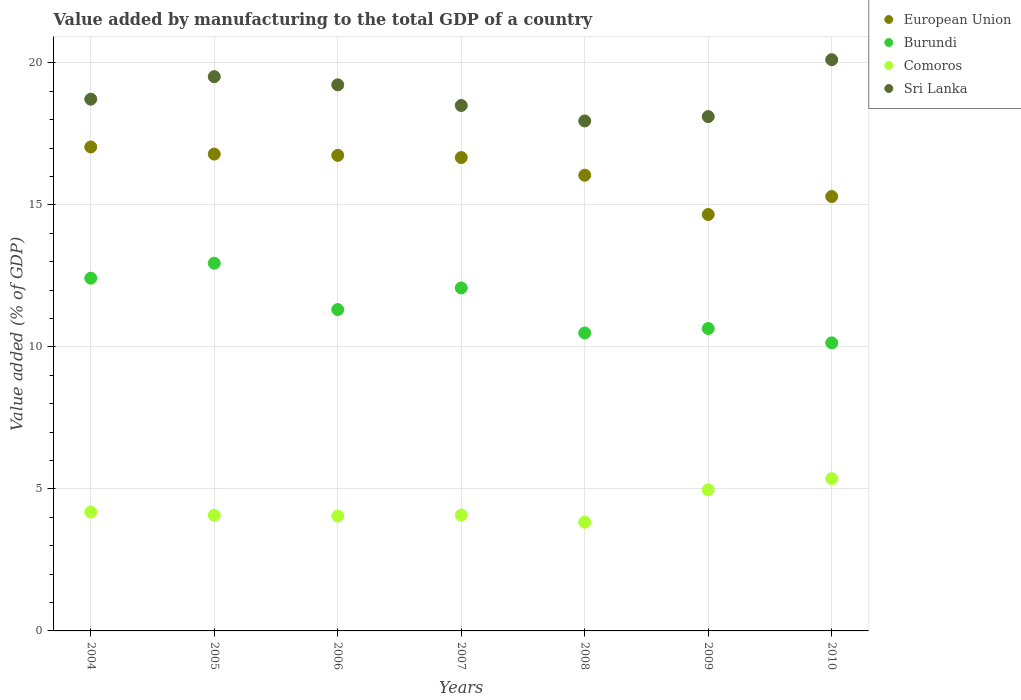What is the value added by manufacturing to the total GDP in Burundi in 2006?
Provide a short and direct response. 11.31. Across all years, what is the maximum value added by manufacturing to the total GDP in Comoros?
Provide a short and direct response. 5.36. Across all years, what is the minimum value added by manufacturing to the total GDP in Comoros?
Offer a terse response. 3.83. In which year was the value added by manufacturing to the total GDP in European Union minimum?
Provide a short and direct response. 2009. What is the total value added by manufacturing to the total GDP in Burundi in the graph?
Give a very brief answer. 80.03. What is the difference between the value added by manufacturing to the total GDP in Comoros in 2004 and that in 2009?
Your response must be concise. -0.78. What is the difference between the value added by manufacturing to the total GDP in Sri Lanka in 2004 and the value added by manufacturing to the total GDP in Burundi in 2007?
Keep it short and to the point. 6.65. What is the average value added by manufacturing to the total GDP in European Union per year?
Provide a succinct answer. 16.18. In the year 2010, what is the difference between the value added by manufacturing to the total GDP in Sri Lanka and value added by manufacturing to the total GDP in European Union?
Offer a very short reply. 4.82. In how many years, is the value added by manufacturing to the total GDP in Burundi greater than 17 %?
Your response must be concise. 0. What is the ratio of the value added by manufacturing to the total GDP in Sri Lanka in 2004 to that in 2007?
Offer a terse response. 1.01. Is the value added by manufacturing to the total GDP in European Union in 2004 less than that in 2007?
Provide a succinct answer. No. Is the difference between the value added by manufacturing to the total GDP in Sri Lanka in 2004 and 2010 greater than the difference between the value added by manufacturing to the total GDP in European Union in 2004 and 2010?
Keep it short and to the point. No. What is the difference between the highest and the second highest value added by manufacturing to the total GDP in Comoros?
Make the answer very short. 0.39. What is the difference between the highest and the lowest value added by manufacturing to the total GDP in Burundi?
Ensure brevity in your answer.  2.8. Is the sum of the value added by manufacturing to the total GDP in Burundi in 2006 and 2007 greater than the maximum value added by manufacturing to the total GDP in Sri Lanka across all years?
Offer a very short reply. Yes. Is it the case that in every year, the sum of the value added by manufacturing to the total GDP in European Union and value added by manufacturing to the total GDP in Sri Lanka  is greater than the sum of value added by manufacturing to the total GDP in Burundi and value added by manufacturing to the total GDP in Comoros?
Your response must be concise. Yes. Is it the case that in every year, the sum of the value added by manufacturing to the total GDP in Sri Lanka and value added by manufacturing to the total GDP in Burundi  is greater than the value added by manufacturing to the total GDP in European Union?
Make the answer very short. Yes. Is the value added by manufacturing to the total GDP in Sri Lanka strictly greater than the value added by manufacturing to the total GDP in Burundi over the years?
Your response must be concise. Yes. Is the value added by manufacturing to the total GDP in Sri Lanka strictly less than the value added by manufacturing to the total GDP in Comoros over the years?
Your answer should be compact. No. How many years are there in the graph?
Your answer should be compact. 7. What is the difference between two consecutive major ticks on the Y-axis?
Offer a terse response. 5. Are the values on the major ticks of Y-axis written in scientific E-notation?
Offer a very short reply. No. Where does the legend appear in the graph?
Provide a succinct answer. Top right. What is the title of the graph?
Provide a succinct answer. Value added by manufacturing to the total GDP of a country. What is the label or title of the Y-axis?
Offer a very short reply. Value added (% of GDP). What is the Value added (% of GDP) in European Union in 2004?
Provide a short and direct response. 17.04. What is the Value added (% of GDP) of Burundi in 2004?
Provide a short and direct response. 12.42. What is the Value added (% of GDP) in Comoros in 2004?
Ensure brevity in your answer.  4.19. What is the Value added (% of GDP) in Sri Lanka in 2004?
Keep it short and to the point. 18.72. What is the Value added (% of GDP) in European Union in 2005?
Make the answer very short. 16.79. What is the Value added (% of GDP) in Burundi in 2005?
Make the answer very short. 12.95. What is the Value added (% of GDP) of Comoros in 2005?
Keep it short and to the point. 4.07. What is the Value added (% of GDP) of Sri Lanka in 2005?
Your response must be concise. 19.51. What is the Value added (% of GDP) of European Union in 2006?
Ensure brevity in your answer.  16.74. What is the Value added (% of GDP) in Burundi in 2006?
Make the answer very short. 11.31. What is the Value added (% of GDP) in Comoros in 2006?
Give a very brief answer. 4.04. What is the Value added (% of GDP) in Sri Lanka in 2006?
Offer a very short reply. 19.23. What is the Value added (% of GDP) of European Union in 2007?
Make the answer very short. 16.67. What is the Value added (% of GDP) in Burundi in 2007?
Provide a succinct answer. 12.07. What is the Value added (% of GDP) in Comoros in 2007?
Keep it short and to the point. 4.08. What is the Value added (% of GDP) in Sri Lanka in 2007?
Make the answer very short. 18.5. What is the Value added (% of GDP) of European Union in 2008?
Give a very brief answer. 16.04. What is the Value added (% of GDP) of Burundi in 2008?
Offer a very short reply. 10.49. What is the Value added (% of GDP) of Comoros in 2008?
Make the answer very short. 3.83. What is the Value added (% of GDP) of Sri Lanka in 2008?
Provide a short and direct response. 17.95. What is the Value added (% of GDP) in European Union in 2009?
Ensure brevity in your answer.  14.66. What is the Value added (% of GDP) in Burundi in 2009?
Your response must be concise. 10.65. What is the Value added (% of GDP) of Comoros in 2009?
Keep it short and to the point. 4.97. What is the Value added (% of GDP) in Sri Lanka in 2009?
Keep it short and to the point. 18.11. What is the Value added (% of GDP) of European Union in 2010?
Your answer should be compact. 15.29. What is the Value added (% of GDP) of Burundi in 2010?
Ensure brevity in your answer.  10.14. What is the Value added (% of GDP) in Comoros in 2010?
Keep it short and to the point. 5.36. What is the Value added (% of GDP) in Sri Lanka in 2010?
Make the answer very short. 20.11. Across all years, what is the maximum Value added (% of GDP) of European Union?
Your answer should be very brief. 17.04. Across all years, what is the maximum Value added (% of GDP) of Burundi?
Make the answer very short. 12.95. Across all years, what is the maximum Value added (% of GDP) of Comoros?
Your response must be concise. 5.36. Across all years, what is the maximum Value added (% of GDP) of Sri Lanka?
Provide a short and direct response. 20.11. Across all years, what is the minimum Value added (% of GDP) of European Union?
Keep it short and to the point. 14.66. Across all years, what is the minimum Value added (% of GDP) of Burundi?
Your answer should be compact. 10.14. Across all years, what is the minimum Value added (% of GDP) of Comoros?
Provide a succinct answer. 3.83. Across all years, what is the minimum Value added (% of GDP) of Sri Lanka?
Ensure brevity in your answer.  17.95. What is the total Value added (% of GDP) of European Union in the graph?
Ensure brevity in your answer.  113.23. What is the total Value added (% of GDP) of Burundi in the graph?
Your response must be concise. 80.03. What is the total Value added (% of GDP) of Comoros in the graph?
Offer a terse response. 30.53. What is the total Value added (% of GDP) in Sri Lanka in the graph?
Your answer should be very brief. 132.13. What is the difference between the Value added (% of GDP) of European Union in 2004 and that in 2005?
Ensure brevity in your answer.  0.25. What is the difference between the Value added (% of GDP) in Burundi in 2004 and that in 2005?
Make the answer very short. -0.53. What is the difference between the Value added (% of GDP) in Comoros in 2004 and that in 2005?
Your response must be concise. 0.12. What is the difference between the Value added (% of GDP) in Sri Lanka in 2004 and that in 2005?
Keep it short and to the point. -0.79. What is the difference between the Value added (% of GDP) in European Union in 2004 and that in 2006?
Your answer should be compact. 0.29. What is the difference between the Value added (% of GDP) in Burundi in 2004 and that in 2006?
Provide a succinct answer. 1.11. What is the difference between the Value added (% of GDP) in Comoros in 2004 and that in 2006?
Make the answer very short. 0.14. What is the difference between the Value added (% of GDP) in Sri Lanka in 2004 and that in 2006?
Offer a very short reply. -0.51. What is the difference between the Value added (% of GDP) in European Union in 2004 and that in 2007?
Your answer should be compact. 0.37. What is the difference between the Value added (% of GDP) in Burundi in 2004 and that in 2007?
Your response must be concise. 0.34. What is the difference between the Value added (% of GDP) in Comoros in 2004 and that in 2007?
Provide a succinct answer. 0.11. What is the difference between the Value added (% of GDP) of Sri Lanka in 2004 and that in 2007?
Make the answer very short. 0.22. What is the difference between the Value added (% of GDP) of European Union in 2004 and that in 2008?
Your response must be concise. 0.99. What is the difference between the Value added (% of GDP) in Burundi in 2004 and that in 2008?
Offer a terse response. 1.93. What is the difference between the Value added (% of GDP) in Comoros in 2004 and that in 2008?
Make the answer very short. 0.36. What is the difference between the Value added (% of GDP) in Sri Lanka in 2004 and that in 2008?
Ensure brevity in your answer.  0.77. What is the difference between the Value added (% of GDP) of European Union in 2004 and that in 2009?
Offer a very short reply. 2.38. What is the difference between the Value added (% of GDP) of Burundi in 2004 and that in 2009?
Give a very brief answer. 1.77. What is the difference between the Value added (% of GDP) in Comoros in 2004 and that in 2009?
Your answer should be very brief. -0.78. What is the difference between the Value added (% of GDP) of Sri Lanka in 2004 and that in 2009?
Ensure brevity in your answer.  0.61. What is the difference between the Value added (% of GDP) in European Union in 2004 and that in 2010?
Ensure brevity in your answer.  1.74. What is the difference between the Value added (% of GDP) of Burundi in 2004 and that in 2010?
Offer a terse response. 2.28. What is the difference between the Value added (% of GDP) of Comoros in 2004 and that in 2010?
Your response must be concise. -1.17. What is the difference between the Value added (% of GDP) of Sri Lanka in 2004 and that in 2010?
Provide a short and direct response. -1.39. What is the difference between the Value added (% of GDP) in European Union in 2005 and that in 2006?
Provide a succinct answer. 0.04. What is the difference between the Value added (% of GDP) of Burundi in 2005 and that in 2006?
Provide a short and direct response. 1.63. What is the difference between the Value added (% of GDP) of Comoros in 2005 and that in 2006?
Offer a terse response. 0.03. What is the difference between the Value added (% of GDP) in Sri Lanka in 2005 and that in 2006?
Make the answer very short. 0.29. What is the difference between the Value added (% of GDP) of European Union in 2005 and that in 2007?
Offer a terse response. 0.12. What is the difference between the Value added (% of GDP) in Burundi in 2005 and that in 2007?
Provide a short and direct response. 0.87. What is the difference between the Value added (% of GDP) of Comoros in 2005 and that in 2007?
Give a very brief answer. -0.01. What is the difference between the Value added (% of GDP) in Sri Lanka in 2005 and that in 2007?
Offer a very short reply. 1.02. What is the difference between the Value added (% of GDP) in European Union in 2005 and that in 2008?
Give a very brief answer. 0.74. What is the difference between the Value added (% of GDP) of Burundi in 2005 and that in 2008?
Your answer should be very brief. 2.46. What is the difference between the Value added (% of GDP) of Comoros in 2005 and that in 2008?
Offer a terse response. 0.24. What is the difference between the Value added (% of GDP) in Sri Lanka in 2005 and that in 2008?
Give a very brief answer. 1.56. What is the difference between the Value added (% of GDP) of European Union in 2005 and that in 2009?
Offer a terse response. 2.13. What is the difference between the Value added (% of GDP) in Burundi in 2005 and that in 2009?
Offer a terse response. 2.3. What is the difference between the Value added (% of GDP) of Comoros in 2005 and that in 2009?
Give a very brief answer. -0.9. What is the difference between the Value added (% of GDP) in Sri Lanka in 2005 and that in 2009?
Your answer should be very brief. 1.41. What is the difference between the Value added (% of GDP) in European Union in 2005 and that in 2010?
Provide a succinct answer. 1.49. What is the difference between the Value added (% of GDP) in Burundi in 2005 and that in 2010?
Provide a succinct answer. 2.8. What is the difference between the Value added (% of GDP) of Comoros in 2005 and that in 2010?
Your response must be concise. -1.29. What is the difference between the Value added (% of GDP) of Sri Lanka in 2005 and that in 2010?
Offer a terse response. -0.6. What is the difference between the Value added (% of GDP) of European Union in 2006 and that in 2007?
Your answer should be compact. 0.08. What is the difference between the Value added (% of GDP) in Burundi in 2006 and that in 2007?
Make the answer very short. -0.76. What is the difference between the Value added (% of GDP) of Comoros in 2006 and that in 2007?
Provide a short and direct response. -0.03. What is the difference between the Value added (% of GDP) in Sri Lanka in 2006 and that in 2007?
Ensure brevity in your answer.  0.73. What is the difference between the Value added (% of GDP) in European Union in 2006 and that in 2008?
Keep it short and to the point. 0.7. What is the difference between the Value added (% of GDP) of Burundi in 2006 and that in 2008?
Your response must be concise. 0.82. What is the difference between the Value added (% of GDP) in Comoros in 2006 and that in 2008?
Keep it short and to the point. 0.22. What is the difference between the Value added (% of GDP) in Sri Lanka in 2006 and that in 2008?
Offer a very short reply. 1.27. What is the difference between the Value added (% of GDP) of European Union in 2006 and that in 2009?
Your answer should be very brief. 2.08. What is the difference between the Value added (% of GDP) of Burundi in 2006 and that in 2009?
Provide a succinct answer. 0.67. What is the difference between the Value added (% of GDP) in Comoros in 2006 and that in 2009?
Provide a short and direct response. -0.92. What is the difference between the Value added (% of GDP) in Sri Lanka in 2006 and that in 2009?
Give a very brief answer. 1.12. What is the difference between the Value added (% of GDP) in European Union in 2006 and that in 2010?
Give a very brief answer. 1.45. What is the difference between the Value added (% of GDP) in Burundi in 2006 and that in 2010?
Provide a short and direct response. 1.17. What is the difference between the Value added (% of GDP) of Comoros in 2006 and that in 2010?
Give a very brief answer. -1.32. What is the difference between the Value added (% of GDP) in Sri Lanka in 2006 and that in 2010?
Your response must be concise. -0.88. What is the difference between the Value added (% of GDP) in European Union in 2007 and that in 2008?
Give a very brief answer. 0.62. What is the difference between the Value added (% of GDP) in Burundi in 2007 and that in 2008?
Offer a terse response. 1.58. What is the difference between the Value added (% of GDP) of Comoros in 2007 and that in 2008?
Ensure brevity in your answer.  0.25. What is the difference between the Value added (% of GDP) of Sri Lanka in 2007 and that in 2008?
Your response must be concise. 0.54. What is the difference between the Value added (% of GDP) of European Union in 2007 and that in 2009?
Your answer should be compact. 2. What is the difference between the Value added (% of GDP) in Burundi in 2007 and that in 2009?
Give a very brief answer. 1.43. What is the difference between the Value added (% of GDP) in Comoros in 2007 and that in 2009?
Provide a succinct answer. -0.89. What is the difference between the Value added (% of GDP) of Sri Lanka in 2007 and that in 2009?
Offer a terse response. 0.39. What is the difference between the Value added (% of GDP) in European Union in 2007 and that in 2010?
Make the answer very short. 1.37. What is the difference between the Value added (% of GDP) in Burundi in 2007 and that in 2010?
Give a very brief answer. 1.93. What is the difference between the Value added (% of GDP) in Comoros in 2007 and that in 2010?
Offer a terse response. -1.28. What is the difference between the Value added (% of GDP) in Sri Lanka in 2007 and that in 2010?
Offer a very short reply. -1.61. What is the difference between the Value added (% of GDP) of European Union in 2008 and that in 2009?
Your answer should be compact. 1.38. What is the difference between the Value added (% of GDP) of Burundi in 2008 and that in 2009?
Keep it short and to the point. -0.16. What is the difference between the Value added (% of GDP) in Comoros in 2008 and that in 2009?
Ensure brevity in your answer.  -1.14. What is the difference between the Value added (% of GDP) in Sri Lanka in 2008 and that in 2009?
Provide a short and direct response. -0.15. What is the difference between the Value added (% of GDP) of European Union in 2008 and that in 2010?
Your answer should be compact. 0.75. What is the difference between the Value added (% of GDP) in Burundi in 2008 and that in 2010?
Keep it short and to the point. 0.35. What is the difference between the Value added (% of GDP) in Comoros in 2008 and that in 2010?
Your answer should be compact. -1.53. What is the difference between the Value added (% of GDP) of Sri Lanka in 2008 and that in 2010?
Ensure brevity in your answer.  -2.16. What is the difference between the Value added (% of GDP) in European Union in 2009 and that in 2010?
Your response must be concise. -0.63. What is the difference between the Value added (% of GDP) of Burundi in 2009 and that in 2010?
Give a very brief answer. 0.5. What is the difference between the Value added (% of GDP) in Comoros in 2009 and that in 2010?
Offer a terse response. -0.39. What is the difference between the Value added (% of GDP) in Sri Lanka in 2009 and that in 2010?
Your answer should be compact. -2. What is the difference between the Value added (% of GDP) of European Union in 2004 and the Value added (% of GDP) of Burundi in 2005?
Ensure brevity in your answer.  4.09. What is the difference between the Value added (% of GDP) in European Union in 2004 and the Value added (% of GDP) in Comoros in 2005?
Ensure brevity in your answer.  12.97. What is the difference between the Value added (% of GDP) of European Union in 2004 and the Value added (% of GDP) of Sri Lanka in 2005?
Your response must be concise. -2.48. What is the difference between the Value added (% of GDP) of Burundi in 2004 and the Value added (% of GDP) of Comoros in 2005?
Your response must be concise. 8.35. What is the difference between the Value added (% of GDP) in Burundi in 2004 and the Value added (% of GDP) in Sri Lanka in 2005?
Ensure brevity in your answer.  -7.09. What is the difference between the Value added (% of GDP) of Comoros in 2004 and the Value added (% of GDP) of Sri Lanka in 2005?
Provide a succinct answer. -15.33. What is the difference between the Value added (% of GDP) in European Union in 2004 and the Value added (% of GDP) in Burundi in 2006?
Offer a very short reply. 5.72. What is the difference between the Value added (% of GDP) in European Union in 2004 and the Value added (% of GDP) in Comoros in 2006?
Your response must be concise. 12.99. What is the difference between the Value added (% of GDP) in European Union in 2004 and the Value added (% of GDP) in Sri Lanka in 2006?
Provide a short and direct response. -2.19. What is the difference between the Value added (% of GDP) in Burundi in 2004 and the Value added (% of GDP) in Comoros in 2006?
Keep it short and to the point. 8.37. What is the difference between the Value added (% of GDP) in Burundi in 2004 and the Value added (% of GDP) in Sri Lanka in 2006?
Your response must be concise. -6.81. What is the difference between the Value added (% of GDP) in Comoros in 2004 and the Value added (% of GDP) in Sri Lanka in 2006?
Ensure brevity in your answer.  -15.04. What is the difference between the Value added (% of GDP) in European Union in 2004 and the Value added (% of GDP) in Burundi in 2007?
Keep it short and to the point. 4.96. What is the difference between the Value added (% of GDP) in European Union in 2004 and the Value added (% of GDP) in Comoros in 2007?
Offer a terse response. 12.96. What is the difference between the Value added (% of GDP) of European Union in 2004 and the Value added (% of GDP) of Sri Lanka in 2007?
Offer a terse response. -1.46. What is the difference between the Value added (% of GDP) of Burundi in 2004 and the Value added (% of GDP) of Comoros in 2007?
Your answer should be very brief. 8.34. What is the difference between the Value added (% of GDP) in Burundi in 2004 and the Value added (% of GDP) in Sri Lanka in 2007?
Offer a very short reply. -6.08. What is the difference between the Value added (% of GDP) of Comoros in 2004 and the Value added (% of GDP) of Sri Lanka in 2007?
Offer a terse response. -14.31. What is the difference between the Value added (% of GDP) in European Union in 2004 and the Value added (% of GDP) in Burundi in 2008?
Ensure brevity in your answer.  6.55. What is the difference between the Value added (% of GDP) in European Union in 2004 and the Value added (% of GDP) in Comoros in 2008?
Keep it short and to the point. 13.21. What is the difference between the Value added (% of GDP) in European Union in 2004 and the Value added (% of GDP) in Sri Lanka in 2008?
Give a very brief answer. -0.92. What is the difference between the Value added (% of GDP) in Burundi in 2004 and the Value added (% of GDP) in Comoros in 2008?
Your answer should be very brief. 8.59. What is the difference between the Value added (% of GDP) of Burundi in 2004 and the Value added (% of GDP) of Sri Lanka in 2008?
Offer a terse response. -5.54. What is the difference between the Value added (% of GDP) in Comoros in 2004 and the Value added (% of GDP) in Sri Lanka in 2008?
Your answer should be compact. -13.77. What is the difference between the Value added (% of GDP) in European Union in 2004 and the Value added (% of GDP) in Burundi in 2009?
Your answer should be very brief. 6.39. What is the difference between the Value added (% of GDP) in European Union in 2004 and the Value added (% of GDP) in Comoros in 2009?
Offer a very short reply. 12.07. What is the difference between the Value added (% of GDP) in European Union in 2004 and the Value added (% of GDP) in Sri Lanka in 2009?
Provide a short and direct response. -1.07. What is the difference between the Value added (% of GDP) of Burundi in 2004 and the Value added (% of GDP) of Comoros in 2009?
Keep it short and to the point. 7.45. What is the difference between the Value added (% of GDP) of Burundi in 2004 and the Value added (% of GDP) of Sri Lanka in 2009?
Your answer should be very brief. -5.69. What is the difference between the Value added (% of GDP) of Comoros in 2004 and the Value added (% of GDP) of Sri Lanka in 2009?
Ensure brevity in your answer.  -13.92. What is the difference between the Value added (% of GDP) of European Union in 2004 and the Value added (% of GDP) of Burundi in 2010?
Offer a terse response. 6.9. What is the difference between the Value added (% of GDP) of European Union in 2004 and the Value added (% of GDP) of Comoros in 2010?
Give a very brief answer. 11.68. What is the difference between the Value added (% of GDP) of European Union in 2004 and the Value added (% of GDP) of Sri Lanka in 2010?
Provide a succinct answer. -3.07. What is the difference between the Value added (% of GDP) of Burundi in 2004 and the Value added (% of GDP) of Comoros in 2010?
Keep it short and to the point. 7.06. What is the difference between the Value added (% of GDP) of Burundi in 2004 and the Value added (% of GDP) of Sri Lanka in 2010?
Give a very brief answer. -7.69. What is the difference between the Value added (% of GDP) of Comoros in 2004 and the Value added (% of GDP) of Sri Lanka in 2010?
Make the answer very short. -15.92. What is the difference between the Value added (% of GDP) in European Union in 2005 and the Value added (% of GDP) in Burundi in 2006?
Your answer should be very brief. 5.47. What is the difference between the Value added (% of GDP) of European Union in 2005 and the Value added (% of GDP) of Comoros in 2006?
Your answer should be very brief. 12.74. What is the difference between the Value added (% of GDP) of European Union in 2005 and the Value added (% of GDP) of Sri Lanka in 2006?
Provide a succinct answer. -2.44. What is the difference between the Value added (% of GDP) in Burundi in 2005 and the Value added (% of GDP) in Comoros in 2006?
Offer a very short reply. 8.9. What is the difference between the Value added (% of GDP) in Burundi in 2005 and the Value added (% of GDP) in Sri Lanka in 2006?
Offer a terse response. -6.28. What is the difference between the Value added (% of GDP) of Comoros in 2005 and the Value added (% of GDP) of Sri Lanka in 2006?
Your answer should be compact. -15.16. What is the difference between the Value added (% of GDP) of European Union in 2005 and the Value added (% of GDP) of Burundi in 2007?
Keep it short and to the point. 4.71. What is the difference between the Value added (% of GDP) in European Union in 2005 and the Value added (% of GDP) in Comoros in 2007?
Your response must be concise. 12.71. What is the difference between the Value added (% of GDP) in European Union in 2005 and the Value added (% of GDP) in Sri Lanka in 2007?
Give a very brief answer. -1.71. What is the difference between the Value added (% of GDP) in Burundi in 2005 and the Value added (% of GDP) in Comoros in 2007?
Your response must be concise. 8.87. What is the difference between the Value added (% of GDP) in Burundi in 2005 and the Value added (% of GDP) in Sri Lanka in 2007?
Offer a very short reply. -5.55. What is the difference between the Value added (% of GDP) of Comoros in 2005 and the Value added (% of GDP) of Sri Lanka in 2007?
Provide a short and direct response. -14.43. What is the difference between the Value added (% of GDP) of European Union in 2005 and the Value added (% of GDP) of Burundi in 2008?
Provide a succinct answer. 6.3. What is the difference between the Value added (% of GDP) in European Union in 2005 and the Value added (% of GDP) in Comoros in 2008?
Offer a terse response. 12.96. What is the difference between the Value added (% of GDP) in European Union in 2005 and the Value added (% of GDP) in Sri Lanka in 2008?
Keep it short and to the point. -1.17. What is the difference between the Value added (% of GDP) in Burundi in 2005 and the Value added (% of GDP) in Comoros in 2008?
Provide a succinct answer. 9.12. What is the difference between the Value added (% of GDP) in Burundi in 2005 and the Value added (% of GDP) in Sri Lanka in 2008?
Offer a terse response. -5.01. What is the difference between the Value added (% of GDP) in Comoros in 2005 and the Value added (% of GDP) in Sri Lanka in 2008?
Keep it short and to the point. -13.88. What is the difference between the Value added (% of GDP) of European Union in 2005 and the Value added (% of GDP) of Burundi in 2009?
Your answer should be very brief. 6.14. What is the difference between the Value added (% of GDP) of European Union in 2005 and the Value added (% of GDP) of Comoros in 2009?
Your answer should be compact. 11.82. What is the difference between the Value added (% of GDP) of European Union in 2005 and the Value added (% of GDP) of Sri Lanka in 2009?
Ensure brevity in your answer.  -1.32. What is the difference between the Value added (% of GDP) of Burundi in 2005 and the Value added (% of GDP) of Comoros in 2009?
Provide a short and direct response. 7.98. What is the difference between the Value added (% of GDP) of Burundi in 2005 and the Value added (% of GDP) of Sri Lanka in 2009?
Make the answer very short. -5.16. What is the difference between the Value added (% of GDP) of Comoros in 2005 and the Value added (% of GDP) of Sri Lanka in 2009?
Offer a terse response. -14.04. What is the difference between the Value added (% of GDP) of European Union in 2005 and the Value added (% of GDP) of Burundi in 2010?
Your response must be concise. 6.64. What is the difference between the Value added (% of GDP) of European Union in 2005 and the Value added (% of GDP) of Comoros in 2010?
Your answer should be very brief. 11.43. What is the difference between the Value added (% of GDP) in European Union in 2005 and the Value added (% of GDP) in Sri Lanka in 2010?
Provide a succinct answer. -3.32. What is the difference between the Value added (% of GDP) of Burundi in 2005 and the Value added (% of GDP) of Comoros in 2010?
Offer a very short reply. 7.59. What is the difference between the Value added (% of GDP) of Burundi in 2005 and the Value added (% of GDP) of Sri Lanka in 2010?
Provide a succinct answer. -7.17. What is the difference between the Value added (% of GDP) of Comoros in 2005 and the Value added (% of GDP) of Sri Lanka in 2010?
Your answer should be very brief. -16.04. What is the difference between the Value added (% of GDP) in European Union in 2006 and the Value added (% of GDP) in Burundi in 2007?
Ensure brevity in your answer.  4.67. What is the difference between the Value added (% of GDP) in European Union in 2006 and the Value added (% of GDP) in Comoros in 2007?
Provide a short and direct response. 12.66. What is the difference between the Value added (% of GDP) of European Union in 2006 and the Value added (% of GDP) of Sri Lanka in 2007?
Provide a succinct answer. -1.76. What is the difference between the Value added (% of GDP) in Burundi in 2006 and the Value added (% of GDP) in Comoros in 2007?
Make the answer very short. 7.23. What is the difference between the Value added (% of GDP) in Burundi in 2006 and the Value added (% of GDP) in Sri Lanka in 2007?
Make the answer very short. -7.18. What is the difference between the Value added (% of GDP) in Comoros in 2006 and the Value added (% of GDP) in Sri Lanka in 2007?
Offer a very short reply. -14.45. What is the difference between the Value added (% of GDP) in European Union in 2006 and the Value added (% of GDP) in Burundi in 2008?
Your response must be concise. 6.25. What is the difference between the Value added (% of GDP) of European Union in 2006 and the Value added (% of GDP) of Comoros in 2008?
Ensure brevity in your answer.  12.91. What is the difference between the Value added (% of GDP) in European Union in 2006 and the Value added (% of GDP) in Sri Lanka in 2008?
Provide a succinct answer. -1.21. What is the difference between the Value added (% of GDP) in Burundi in 2006 and the Value added (% of GDP) in Comoros in 2008?
Offer a very short reply. 7.48. What is the difference between the Value added (% of GDP) in Burundi in 2006 and the Value added (% of GDP) in Sri Lanka in 2008?
Your answer should be very brief. -6.64. What is the difference between the Value added (% of GDP) of Comoros in 2006 and the Value added (% of GDP) of Sri Lanka in 2008?
Provide a succinct answer. -13.91. What is the difference between the Value added (% of GDP) in European Union in 2006 and the Value added (% of GDP) in Burundi in 2009?
Provide a short and direct response. 6.1. What is the difference between the Value added (% of GDP) of European Union in 2006 and the Value added (% of GDP) of Comoros in 2009?
Ensure brevity in your answer.  11.78. What is the difference between the Value added (% of GDP) in European Union in 2006 and the Value added (% of GDP) in Sri Lanka in 2009?
Provide a succinct answer. -1.36. What is the difference between the Value added (% of GDP) of Burundi in 2006 and the Value added (% of GDP) of Comoros in 2009?
Your answer should be very brief. 6.35. What is the difference between the Value added (% of GDP) of Burundi in 2006 and the Value added (% of GDP) of Sri Lanka in 2009?
Keep it short and to the point. -6.79. What is the difference between the Value added (% of GDP) of Comoros in 2006 and the Value added (% of GDP) of Sri Lanka in 2009?
Provide a short and direct response. -14.06. What is the difference between the Value added (% of GDP) in European Union in 2006 and the Value added (% of GDP) in Burundi in 2010?
Give a very brief answer. 6.6. What is the difference between the Value added (% of GDP) of European Union in 2006 and the Value added (% of GDP) of Comoros in 2010?
Provide a succinct answer. 11.38. What is the difference between the Value added (% of GDP) in European Union in 2006 and the Value added (% of GDP) in Sri Lanka in 2010?
Give a very brief answer. -3.37. What is the difference between the Value added (% of GDP) of Burundi in 2006 and the Value added (% of GDP) of Comoros in 2010?
Your response must be concise. 5.95. What is the difference between the Value added (% of GDP) in Burundi in 2006 and the Value added (% of GDP) in Sri Lanka in 2010?
Offer a very short reply. -8.8. What is the difference between the Value added (% of GDP) of Comoros in 2006 and the Value added (% of GDP) of Sri Lanka in 2010?
Offer a terse response. -16.07. What is the difference between the Value added (% of GDP) of European Union in 2007 and the Value added (% of GDP) of Burundi in 2008?
Ensure brevity in your answer.  6.18. What is the difference between the Value added (% of GDP) in European Union in 2007 and the Value added (% of GDP) in Comoros in 2008?
Your answer should be very brief. 12.84. What is the difference between the Value added (% of GDP) of European Union in 2007 and the Value added (% of GDP) of Sri Lanka in 2008?
Ensure brevity in your answer.  -1.29. What is the difference between the Value added (% of GDP) in Burundi in 2007 and the Value added (% of GDP) in Comoros in 2008?
Ensure brevity in your answer.  8.25. What is the difference between the Value added (% of GDP) of Burundi in 2007 and the Value added (% of GDP) of Sri Lanka in 2008?
Make the answer very short. -5.88. What is the difference between the Value added (% of GDP) in Comoros in 2007 and the Value added (% of GDP) in Sri Lanka in 2008?
Your response must be concise. -13.88. What is the difference between the Value added (% of GDP) in European Union in 2007 and the Value added (% of GDP) in Burundi in 2009?
Offer a terse response. 6.02. What is the difference between the Value added (% of GDP) in European Union in 2007 and the Value added (% of GDP) in Comoros in 2009?
Ensure brevity in your answer.  11.7. What is the difference between the Value added (% of GDP) in European Union in 2007 and the Value added (% of GDP) in Sri Lanka in 2009?
Offer a very short reply. -1.44. What is the difference between the Value added (% of GDP) of Burundi in 2007 and the Value added (% of GDP) of Comoros in 2009?
Provide a succinct answer. 7.11. What is the difference between the Value added (% of GDP) in Burundi in 2007 and the Value added (% of GDP) in Sri Lanka in 2009?
Your answer should be very brief. -6.03. What is the difference between the Value added (% of GDP) of Comoros in 2007 and the Value added (% of GDP) of Sri Lanka in 2009?
Provide a short and direct response. -14.03. What is the difference between the Value added (% of GDP) in European Union in 2007 and the Value added (% of GDP) in Burundi in 2010?
Give a very brief answer. 6.52. What is the difference between the Value added (% of GDP) in European Union in 2007 and the Value added (% of GDP) in Comoros in 2010?
Offer a terse response. 11.31. What is the difference between the Value added (% of GDP) in European Union in 2007 and the Value added (% of GDP) in Sri Lanka in 2010?
Your response must be concise. -3.45. What is the difference between the Value added (% of GDP) of Burundi in 2007 and the Value added (% of GDP) of Comoros in 2010?
Offer a very short reply. 6.72. What is the difference between the Value added (% of GDP) in Burundi in 2007 and the Value added (% of GDP) in Sri Lanka in 2010?
Keep it short and to the point. -8.04. What is the difference between the Value added (% of GDP) of Comoros in 2007 and the Value added (% of GDP) of Sri Lanka in 2010?
Provide a succinct answer. -16.03. What is the difference between the Value added (% of GDP) in European Union in 2008 and the Value added (% of GDP) in Burundi in 2009?
Keep it short and to the point. 5.4. What is the difference between the Value added (% of GDP) of European Union in 2008 and the Value added (% of GDP) of Comoros in 2009?
Your answer should be compact. 11.08. What is the difference between the Value added (% of GDP) of European Union in 2008 and the Value added (% of GDP) of Sri Lanka in 2009?
Provide a short and direct response. -2.06. What is the difference between the Value added (% of GDP) of Burundi in 2008 and the Value added (% of GDP) of Comoros in 2009?
Make the answer very short. 5.52. What is the difference between the Value added (% of GDP) of Burundi in 2008 and the Value added (% of GDP) of Sri Lanka in 2009?
Your response must be concise. -7.62. What is the difference between the Value added (% of GDP) of Comoros in 2008 and the Value added (% of GDP) of Sri Lanka in 2009?
Offer a very short reply. -14.28. What is the difference between the Value added (% of GDP) in European Union in 2008 and the Value added (% of GDP) in Burundi in 2010?
Your response must be concise. 5.9. What is the difference between the Value added (% of GDP) in European Union in 2008 and the Value added (% of GDP) in Comoros in 2010?
Offer a terse response. 10.68. What is the difference between the Value added (% of GDP) of European Union in 2008 and the Value added (% of GDP) of Sri Lanka in 2010?
Your response must be concise. -4.07. What is the difference between the Value added (% of GDP) in Burundi in 2008 and the Value added (% of GDP) in Comoros in 2010?
Provide a short and direct response. 5.13. What is the difference between the Value added (% of GDP) in Burundi in 2008 and the Value added (% of GDP) in Sri Lanka in 2010?
Keep it short and to the point. -9.62. What is the difference between the Value added (% of GDP) in Comoros in 2008 and the Value added (% of GDP) in Sri Lanka in 2010?
Offer a terse response. -16.28. What is the difference between the Value added (% of GDP) in European Union in 2009 and the Value added (% of GDP) in Burundi in 2010?
Offer a terse response. 4.52. What is the difference between the Value added (% of GDP) in European Union in 2009 and the Value added (% of GDP) in Comoros in 2010?
Your response must be concise. 9.3. What is the difference between the Value added (% of GDP) in European Union in 2009 and the Value added (% of GDP) in Sri Lanka in 2010?
Your answer should be compact. -5.45. What is the difference between the Value added (% of GDP) in Burundi in 2009 and the Value added (% of GDP) in Comoros in 2010?
Offer a very short reply. 5.29. What is the difference between the Value added (% of GDP) in Burundi in 2009 and the Value added (% of GDP) in Sri Lanka in 2010?
Make the answer very short. -9.46. What is the difference between the Value added (% of GDP) in Comoros in 2009 and the Value added (% of GDP) in Sri Lanka in 2010?
Provide a short and direct response. -15.14. What is the average Value added (% of GDP) of European Union per year?
Provide a succinct answer. 16.18. What is the average Value added (% of GDP) in Burundi per year?
Your response must be concise. 11.43. What is the average Value added (% of GDP) of Comoros per year?
Ensure brevity in your answer.  4.36. What is the average Value added (% of GDP) of Sri Lanka per year?
Ensure brevity in your answer.  18.88. In the year 2004, what is the difference between the Value added (% of GDP) of European Union and Value added (% of GDP) of Burundi?
Give a very brief answer. 4.62. In the year 2004, what is the difference between the Value added (% of GDP) of European Union and Value added (% of GDP) of Comoros?
Your answer should be very brief. 12.85. In the year 2004, what is the difference between the Value added (% of GDP) of European Union and Value added (% of GDP) of Sri Lanka?
Give a very brief answer. -1.68. In the year 2004, what is the difference between the Value added (% of GDP) of Burundi and Value added (% of GDP) of Comoros?
Offer a terse response. 8.23. In the year 2004, what is the difference between the Value added (% of GDP) in Burundi and Value added (% of GDP) in Sri Lanka?
Offer a very short reply. -6.3. In the year 2004, what is the difference between the Value added (% of GDP) of Comoros and Value added (% of GDP) of Sri Lanka?
Give a very brief answer. -14.53. In the year 2005, what is the difference between the Value added (% of GDP) of European Union and Value added (% of GDP) of Burundi?
Provide a short and direct response. 3.84. In the year 2005, what is the difference between the Value added (% of GDP) in European Union and Value added (% of GDP) in Comoros?
Your answer should be very brief. 12.72. In the year 2005, what is the difference between the Value added (% of GDP) in European Union and Value added (% of GDP) in Sri Lanka?
Provide a short and direct response. -2.73. In the year 2005, what is the difference between the Value added (% of GDP) of Burundi and Value added (% of GDP) of Comoros?
Your response must be concise. 8.87. In the year 2005, what is the difference between the Value added (% of GDP) in Burundi and Value added (% of GDP) in Sri Lanka?
Ensure brevity in your answer.  -6.57. In the year 2005, what is the difference between the Value added (% of GDP) in Comoros and Value added (% of GDP) in Sri Lanka?
Your answer should be compact. -15.44. In the year 2006, what is the difference between the Value added (% of GDP) of European Union and Value added (% of GDP) of Burundi?
Your answer should be compact. 5.43. In the year 2006, what is the difference between the Value added (% of GDP) in European Union and Value added (% of GDP) in Comoros?
Your answer should be very brief. 12.7. In the year 2006, what is the difference between the Value added (% of GDP) of European Union and Value added (% of GDP) of Sri Lanka?
Offer a terse response. -2.48. In the year 2006, what is the difference between the Value added (% of GDP) in Burundi and Value added (% of GDP) in Comoros?
Your response must be concise. 7.27. In the year 2006, what is the difference between the Value added (% of GDP) in Burundi and Value added (% of GDP) in Sri Lanka?
Provide a succinct answer. -7.91. In the year 2006, what is the difference between the Value added (% of GDP) in Comoros and Value added (% of GDP) in Sri Lanka?
Ensure brevity in your answer.  -15.18. In the year 2007, what is the difference between the Value added (% of GDP) in European Union and Value added (% of GDP) in Burundi?
Your response must be concise. 4.59. In the year 2007, what is the difference between the Value added (% of GDP) in European Union and Value added (% of GDP) in Comoros?
Your answer should be very brief. 12.59. In the year 2007, what is the difference between the Value added (% of GDP) of European Union and Value added (% of GDP) of Sri Lanka?
Ensure brevity in your answer.  -1.83. In the year 2007, what is the difference between the Value added (% of GDP) of Burundi and Value added (% of GDP) of Comoros?
Your answer should be compact. 8. In the year 2007, what is the difference between the Value added (% of GDP) in Burundi and Value added (% of GDP) in Sri Lanka?
Provide a succinct answer. -6.42. In the year 2007, what is the difference between the Value added (% of GDP) in Comoros and Value added (% of GDP) in Sri Lanka?
Keep it short and to the point. -14.42. In the year 2008, what is the difference between the Value added (% of GDP) of European Union and Value added (% of GDP) of Burundi?
Offer a very short reply. 5.55. In the year 2008, what is the difference between the Value added (% of GDP) of European Union and Value added (% of GDP) of Comoros?
Offer a very short reply. 12.22. In the year 2008, what is the difference between the Value added (% of GDP) in European Union and Value added (% of GDP) in Sri Lanka?
Your answer should be compact. -1.91. In the year 2008, what is the difference between the Value added (% of GDP) of Burundi and Value added (% of GDP) of Comoros?
Give a very brief answer. 6.66. In the year 2008, what is the difference between the Value added (% of GDP) of Burundi and Value added (% of GDP) of Sri Lanka?
Your response must be concise. -7.46. In the year 2008, what is the difference between the Value added (% of GDP) in Comoros and Value added (% of GDP) in Sri Lanka?
Provide a succinct answer. -14.13. In the year 2009, what is the difference between the Value added (% of GDP) of European Union and Value added (% of GDP) of Burundi?
Provide a succinct answer. 4.01. In the year 2009, what is the difference between the Value added (% of GDP) in European Union and Value added (% of GDP) in Comoros?
Make the answer very short. 9.69. In the year 2009, what is the difference between the Value added (% of GDP) in European Union and Value added (% of GDP) in Sri Lanka?
Offer a very short reply. -3.45. In the year 2009, what is the difference between the Value added (% of GDP) in Burundi and Value added (% of GDP) in Comoros?
Your answer should be compact. 5.68. In the year 2009, what is the difference between the Value added (% of GDP) in Burundi and Value added (% of GDP) in Sri Lanka?
Offer a very short reply. -7.46. In the year 2009, what is the difference between the Value added (% of GDP) in Comoros and Value added (% of GDP) in Sri Lanka?
Your response must be concise. -13.14. In the year 2010, what is the difference between the Value added (% of GDP) in European Union and Value added (% of GDP) in Burundi?
Provide a succinct answer. 5.15. In the year 2010, what is the difference between the Value added (% of GDP) in European Union and Value added (% of GDP) in Comoros?
Keep it short and to the point. 9.93. In the year 2010, what is the difference between the Value added (% of GDP) of European Union and Value added (% of GDP) of Sri Lanka?
Your response must be concise. -4.82. In the year 2010, what is the difference between the Value added (% of GDP) of Burundi and Value added (% of GDP) of Comoros?
Offer a very short reply. 4.78. In the year 2010, what is the difference between the Value added (% of GDP) of Burundi and Value added (% of GDP) of Sri Lanka?
Your answer should be compact. -9.97. In the year 2010, what is the difference between the Value added (% of GDP) of Comoros and Value added (% of GDP) of Sri Lanka?
Offer a very short reply. -14.75. What is the ratio of the Value added (% of GDP) in European Union in 2004 to that in 2005?
Provide a short and direct response. 1.01. What is the ratio of the Value added (% of GDP) of Burundi in 2004 to that in 2005?
Give a very brief answer. 0.96. What is the ratio of the Value added (% of GDP) of Comoros in 2004 to that in 2005?
Give a very brief answer. 1.03. What is the ratio of the Value added (% of GDP) of Sri Lanka in 2004 to that in 2005?
Offer a terse response. 0.96. What is the ratio of the Value added (% of GDP) of European Union in 2004 to that in 2006?
Keep it short and to the point. 1.02. What is the ratio of the Value added (% of GDP) in Burundi in 2004 to that in 2006?
Make the answer very short. 1.1. What is the ratio of the Value added (% of GDP) in Comoros in 2004 to that in 2006?
Your answer should be very brief. 1.03. What is the ratio of the Value added (% of GDP) of Sri Lanka in 2004 to that in 2006?
Give a very brief answer. 0.97. What is the ratio of the Value added (% of GDP) of European Union in 2004 to that in 2007?
Your answer should be compact. 1.02. What is the ratio of the Value added (% of GDP) in Burundi in 2004 to that in 2007?
Ensure brevity in your answer.  1.03. What is the ratio of the Value added (% of GDP) in Comoros in 2004 to that in 2007?
Your response must be concise. 1.03. What is the ratio of the Value added (% of GDP) in Sri Lanka in 2004 to that in 2007?
Your response must be concise. 1.01. What is the ratio of the Value added (% of GDP) of European Union in 2004 to that in 2008?
Ensure brevity in your answer.  1.06. What is the ratio of the Value added (% of GDP) in Burundi in 2004 to that in 2008?
Offer a very short reply. 1.18. What is the ratio of the Value added (% of GDP) in Comoros in 2004 to that in 2008?
Make the answer very short. 1.09. What is the ratio of the Value added (% of GDP) of Sri Lanka in 2004 to that in 2008?
Provide a succinct answer. 1.04. What is the ratio of the Value added (% of GDP) in European Union in 2004 to that in 2009?
Ensure brevity in your answer.  1.16. What is the ratio of the Value added (% of GDP) in Burundi in 2004 to that in 2009?
Your response must be concise. 1.17. What is the ratio of the Value added (% of GDP) in Comoros in 2004 to that in 2009?
Offer a very short reply. 0.84. What is the ratio of the Value added (% of GDP) in Sri Lanka in 2004 to that in 2009?
Your response must be concise. 1.03. What is the ratio of the Value added (% of GDP) in European Union in 2004 to that in 2010?
Give a very brief answer. 1.11. What is the ratio of the Value added (% of GDP) of Burundi in 2004 to that in 2010?
Provide a short and direct response. 1.22. What is the ratio of the Value added (% of GDP) of Comoros in 2004 to that in 2010?
Offer a very short reply. 0.78. What is the ratio of the Value added (% of GDP) in Sri Lanka in 2004 to that in 2010?
Your answer should be very brief. 0.93. What is the ratio of the Value added (% of GDP) of Burundi in 2005 to that in 2006?
Provide a succinct answer. 1.14. What is the ratio of the Value added (% of GDP) in Comoros in 2005 to that in 2006?
Provide a succinct answer. 1.01. What is the ratio of the Value added (% of GDP) in Sri Lanka in 2005 to that in 2006?
Your answer should be compact. 1.01. What is the ratio of the Value added (% of GDP) in European Union in 2005 to that in 2007?
Offer a very short reply. 1.01. What is the ratio of the Value added (% of GDP) of Burundi in 2005 to that in 2007?
Your answer should be very brief. 1.07. What is the ratio of the Value added (% of GDP) in Comoros in 2005 to that in 2007?
Keep it short and to the point. 1. What is the ratio of the Value added (% of GDP) of Sri Lanka in 2005 to that in 2007?
Offer a terse response. 1.05. What is the ratio of the Value added (% of GDP) of European Union in 2005 to that in 2008?
Ensure brevity in your answer.  1.05. What is the ratio of the Value added (% of GDP) in Burundi in 2005 to that in 2008?
Offer a very short reply. 1.23. What is the ratio of the Value added (% of GDP) of Comoros in 2005 to that in 2008?
Your answer should be compact. 1.06. What is the ratio of the Value added (% of GDP) of Sri Lanka in 2005 to that in 2008?
Keep it short and to the point. 1.09. What is the ratio of the Value added (% of GDP) of European Union in 2005 to that in 2009?
Give a very brief answer. 1.15. What is the ratio of the Value added (% of GDP) of Burundi in 2005 to that in 2009?
Ensure brevity in your answer.  1.22. What is the ratio of the Value added (% of GDP) in Comoros in 2005 to that in 2009?
Make the answer very short. 0.82. What is the ratio of the Value added (% of GDP) of Sri Lanka in 2005 to that in 2009?
Your answer should be very brief. 1.08. What is the ratio of the Value added (% of GDP) of European Union in 2005 to that in 2010?
Offer a terse response. 1.1. What is the ratio of the Value added (% of GDP) of Burundi in 2005 to that in 2010?
Ensure brevity in your answer.  1.28. What is the ratio of the Value added (% of GDP) in Comoros in 2005 to that in 2010?
Offer a terse response. 0.76. What is the ratio of the Value added (% of GDP) of Sri Lanka in 2005 to that in 2010?
Offer a very short reply. 0.97. What is the ratio of the Value added (% of GDP) of Burundi in 2006 to that in 2007?
Ensure brevity in your answer.  0.94. What is the ratio of the Value added (% of GDP) of Comoros in 2006 to that in 2007?
Offer a terse response. 0.99. What is the ratio of the Value added (% of GDP) in Sri Lanka in 2006 to that in 2007?
Offer a very short reply. 1.04. What is the ratio of the Value added (% of GDP) in European Union in 2006 to that in 2008?
Offer a very short reply. 1.04. What is the ratio of the Value added (% of GDP) in Burundi in 2006 to that in 2008?
Your answer should be compact. 1.08. What is the ratio of the Value added (% of GDP) of Comoros in 2006 to that in 2008?
Provide a succinct answer. 1.06. What is the ratio of the Value added (% of GDP) of Sri Lanka in 2006 to that in 2008?
Give a very brief answer. 1.07. What is the ratio of the Value added (% of GDP) of European Union in 2006 to that in 2009?
Keep it short and to the point. 1.14. What is the ratio of the Value added (% of GDP) in Burundi in 2006 to that in 2009?
Offer a terse response. 1.06. What is the ratio of the Value added (% of GDP) of Comoros in 2006 to that in 2009?
Offer a very short reply. 0.81. What is the ratio of the Value added (% of GDP) in Sri Lanka in 2006 to that in 2009?
Your answer should be very brief. 1.06. What is the ratio of the Value added (% of GDP) in European Union in 2006 to that in 2010?
Your answer should be compact. 1.09. What is the ratio of the Value added (% of GDP) of Burundi in 2006 to that in 2010?
Ensure brevity in your answer.  1.12. What is the ratio of the Value added (% of GDP) of Comoros in 2006 to that in 2010?
Provide a short and direct response. 0.75. What is the ratio of the Value added (% of GDP) in Sri Lanka in 2006 to that in 2010?
Your answer should be compact. 0.96. What is the ratio of the Value added (% of GDP) of European Union in 2007 to that in 2008?
Make the answer very short. 1.04. What is the ratio of the Value added (% of GDP) in Burundi in 2007 to that in 2008?
Your answer should be very brief. 1.15. What is the ratio of the Value added (% of GDP) of Comoros in 2007 to that in 2008?
Offer a terse response. 1.07. What is the ratio of the Value added (% of GDP) of Sri Lanka in 2007 to that in 2008?
Ensure brevity in your answer.  1.03. What is the ratio of the Value added (% of GDP) in European Union in 2007 to that in 2009?
Offer a very short reply. 1.14. What is the ratio of the Value added (% of GDP) of Burundi in 2007 to that in 2009?
Your response must be concise. 1.13. What is the ratio of the Value added (% of GDP) of Comoros in 2007 to that in 2009?
Keep it short and to the point. 0.82. What is the ratio of the Value added (% of GDP) of Sri Lanka in 2007 to that in 2009?
Offer a very short reply. 1.02. What is the ratio of the Value added (% of GDP) of European Union in 2007 to that in 2010?
Keep it short and to the point. 1.09. What is the ratio of the Value added (% of GDP) of Burundi in 2007 to that in 2010?
Offer a very short reply. 1.19. What is the ratio of the Value added (% of GDP) in Comoros in 2007 to that in 2010?
Provide a succinct answer. 0.76. What is the ratio of the Value added (% of GDP) in Sri Lanka in 2007 to that in 2010?
Your response must be concise. 0.92. What is the ratio of the Value added (% of GDP) in European Union in 2008 to that in 2009?
Make the answer very short. 1.09. What is the ratio of the Value added (% of GDP) in Comoros in 2008 to that in 2009?
Give a very brief answer. 0.77. What is the ratio of the Value added (% of GDP) of Sri Lanka in 2008 to that in 2009?
Provide a succinct answer. 0.99. What is the ratio of the Value added (% of GDP) in European Union in 2008 to that in 2010?
Give a very brief answer. 1.05. What is the ratio of the Value added (% of GDP) in Burundi in 2008 to that in 2010?
Your answer should be compact. 1.03. What is the ratio of the Value added (% of GDP) of Comoros in 2008 to that in 2010?
Provide a succinct answer. 0.71. What is the ratio of the Value added (% of GDP) in Sri Lanka in 2008 to that in 2010?
Make the answer very short. 0.89. What is the ratio of the Value added (% of GDP) in European Union in 2009 to that in 2010?
Offer a terse response. 0.96. What is the ratio of the Value added (% of GDP) of Burundi in 2009 to that in 2010?
Offer a terse response. 1.05. What is the ratio of the Value added (% of GDP) of Comoros in 2009 to that in 2010?
Keep it short and to the point. 0.93. What is the ratio of the Value added (% of GDP) in Sri Lanka in 2009 to that in 2010?
Make the answer very short. 0.9. What is the difference between the highest and the second highest Value added (% of GDP) of European Union?
Make the answer very short. 0.25. What is the difference between the highest and the second highest Value added (% of GDP) in Burundi?
Your answer should be compact. 0.53. What is the difference between the highest and the second highest Value added (% of GDP) in Comoros?
Your answer should be very brief. 0.39. What is the difference between the highest and the second highest Value added (% of GDP) in Sri Lanka?
Provide a succinct answer. 0.6. What is the difference between the highest and the lowest Value added (% of GDP) in European Union?
Your answer should be compact. 2.38. What is the difference between the highest and the lowest Value added (% of GDP) in Burundi?
Make the answer very short. 2.8. What is the difference between the highest and the lowest Value added (% of GDP) of Comoros?
Offer a terse response. 1.53. What is the difference between the highest and the lowest Value added (% of GDP) of Sri Lanka?
Keep it short and to the point. 2.16. 